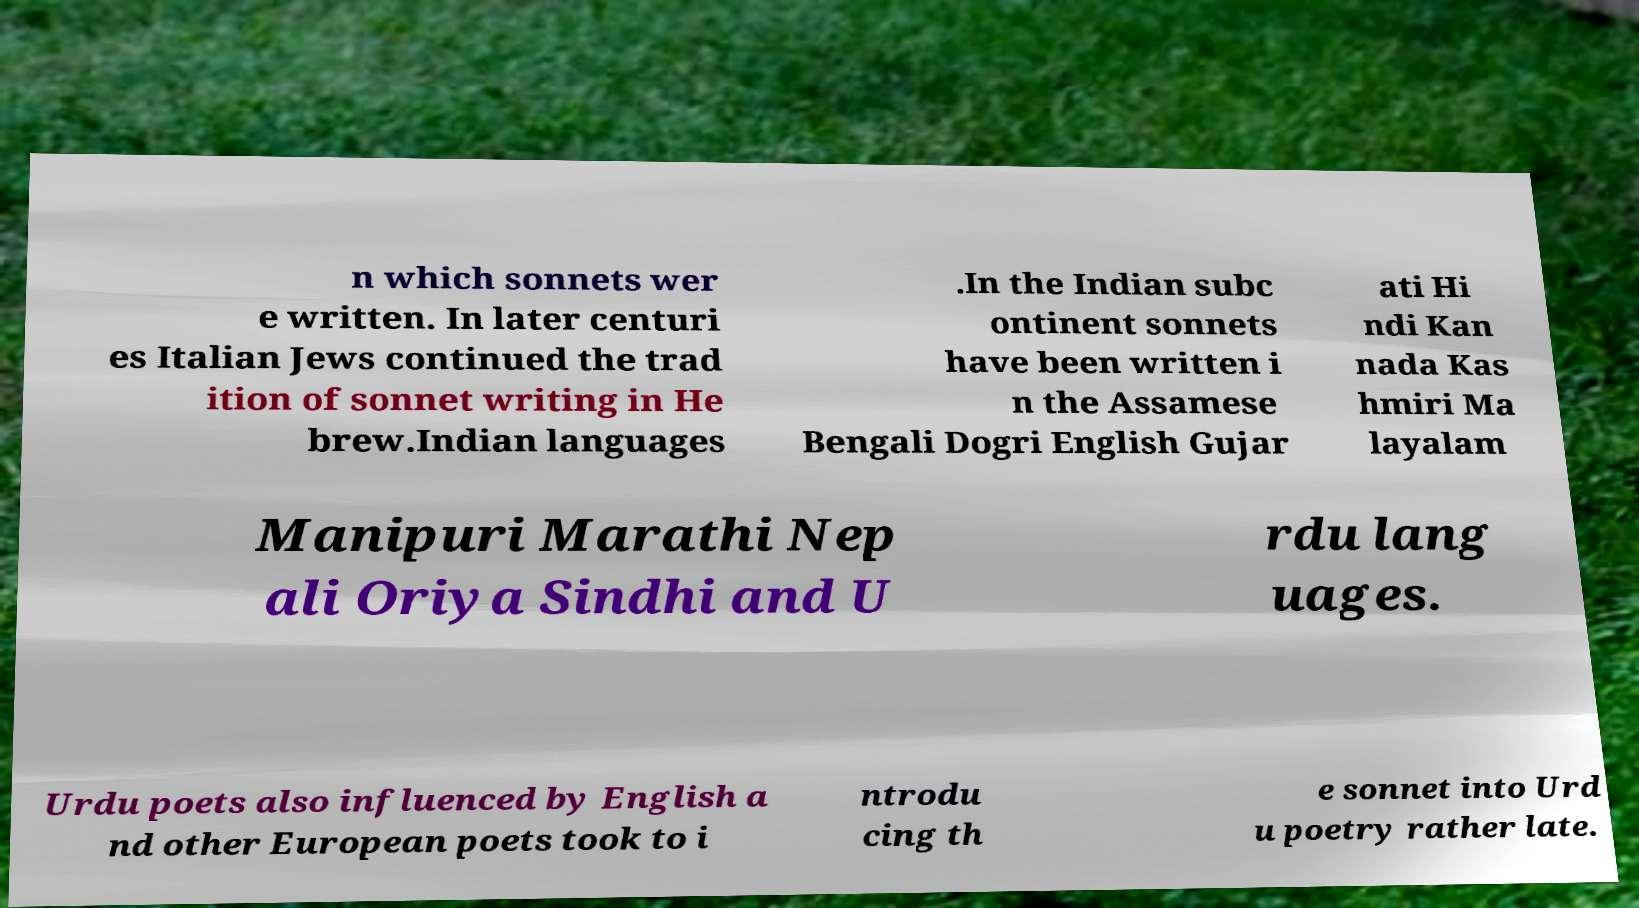For documentation purposes, I need the text within this image transcribed. Could you provide that? n which sonnets wer e written. In later centuri es Italian Jews continued the trad ition of sonnet writing in He brew.Indian languages .In the Indian subc ontinent sonnets have been written i n the Assamese Bengali Dogri English Gujar ati Hi ndi Kan nada Kas hmiri Ma layalam Manipuri Marathi Nep ali Oriya Sindhi and U rdu lang uages. Urdu poets also influenced by English a nd other European poets took to i ntrodu cing th e sonnet into Urd u poetry rather late. 